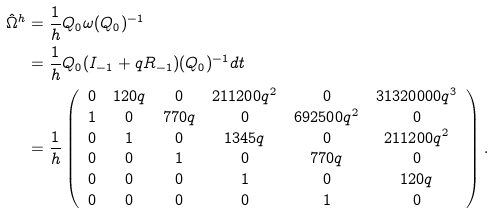<formula> <loc_0><loc_0><loc_500><loc_500>\hat { \Omega } ^ { h } & = \frac { 1 } { h } Q _ { 0 } \omega ( Q _ { 0 } ) ^ { - 1 } \\ & = \frac { 1 } { h } Q _ { 0 } ( I _ { - 1 } + q R _ { - 1 } ) ( Q _ { 0 } ) ^ { - 1 } d t \\ & = \frac { 1 } { h } \left ( \begin{array} { c c c c c c } 0 & 1 2 0 q & 0 & 2 1 1 2 0 0 q ^ { 2 } & 0 & 3 1 3 2 0 0 0 0 q ^ { 3 } \\ 1 & 0 & 7 7 0 q & 0 & 6 9 2 5 0 0 q ^ { 2 } & 0 \\ 0 & 1 & 0 & 1 3 4 5 q & 0 & 2 1 1 2 0 0 q ^ { 2 } \\ 0 & 0 & 1 & 0 & 7 7 0 q & 0 \\ 0 & 0 & 0 & 1 & 0 & 1 2 0 q \\ 0 & 0 & 0 & 0 & 1 & 0 \\ \end{array} \right ) .</formula> 